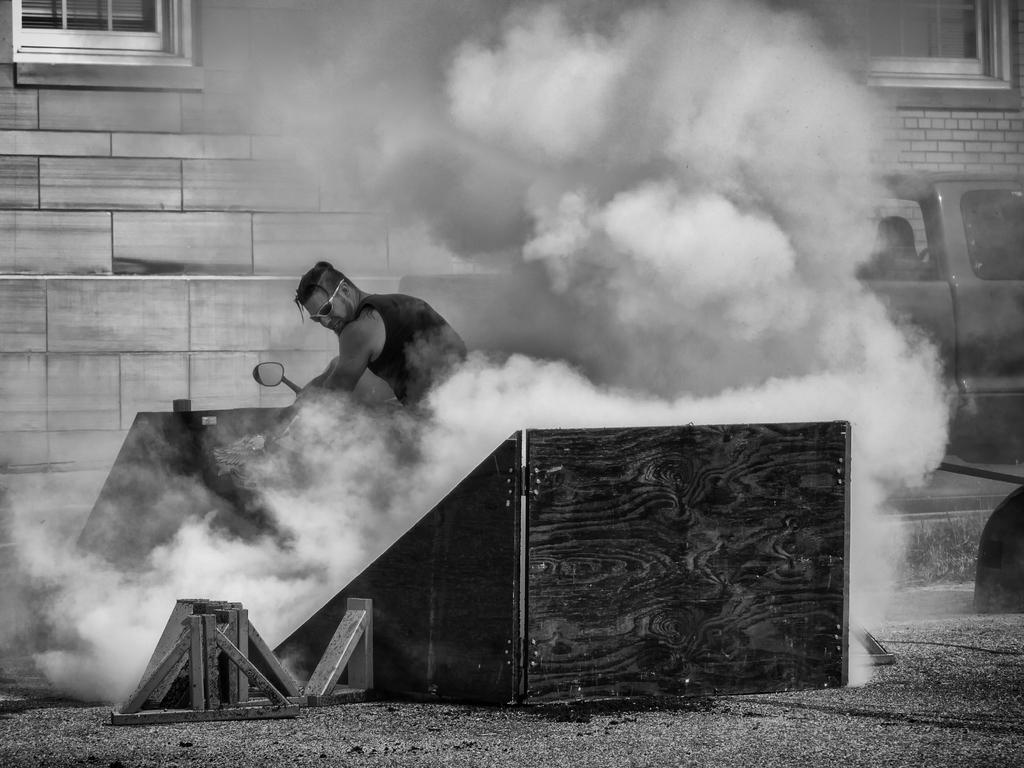What is the man in the image doing? The man is standing in a wooden box. What can be seen in the background of the image? There is a building and a car in the background of the image. What letter is the man holding in the image? There is no letter present in the image; the man is standing in a wooden box. What sound does the whistle make in the image? There is no whistle present in the image. 